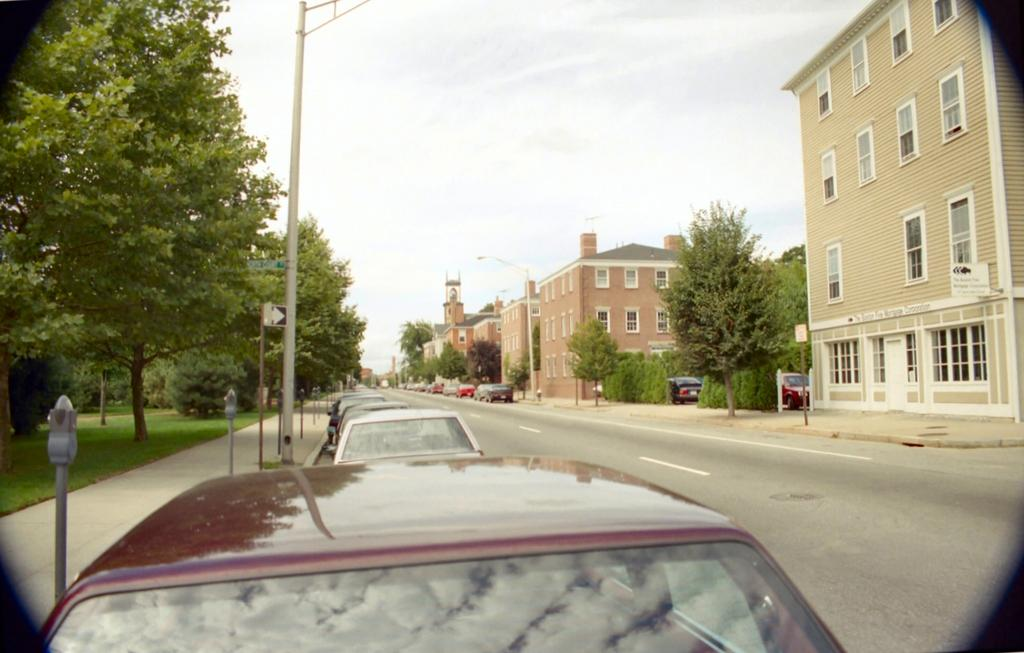What type of structures are located on the right side of the image? There are buildings on the right side of the image. What else can be seen on the right side of the image? There are cars on the right side of the image. What type of vegetation is on the left side of the image? There are trees on the left side of the image. What is visible on the road in the image? There are cars on the road in the image. What might provide illumination at night in the image? There are street lights in the image. Where is the table located in the image? There is no table present in the image. What type of ship can be seen sailing in the image? There is no ship present in the image. 